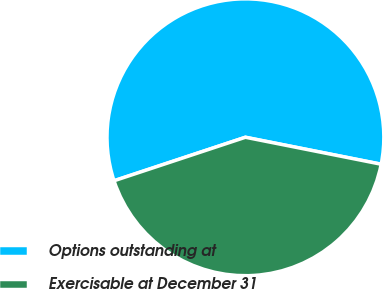Convert chart to OTSL. <chart><loc_0><loc_0><loc_500><loc_500><pie_chart><fcel>Options outstanding at<fcel>Exercisable at December 31<nl><fcel>58.21%<fcel>41.79%<nl></chart> 